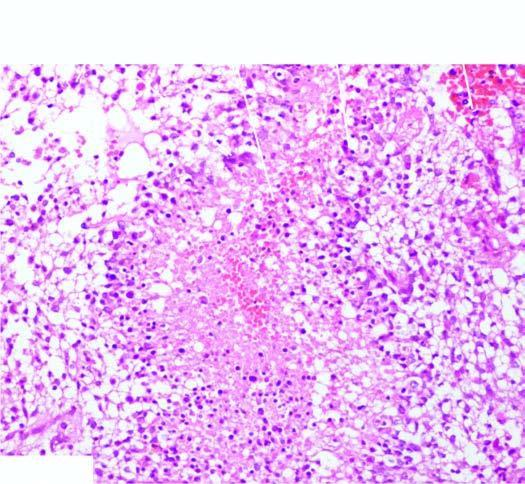what is the tumour?
Answer the question using a single word or phrase. Densely cellular having marked pleomorphism 